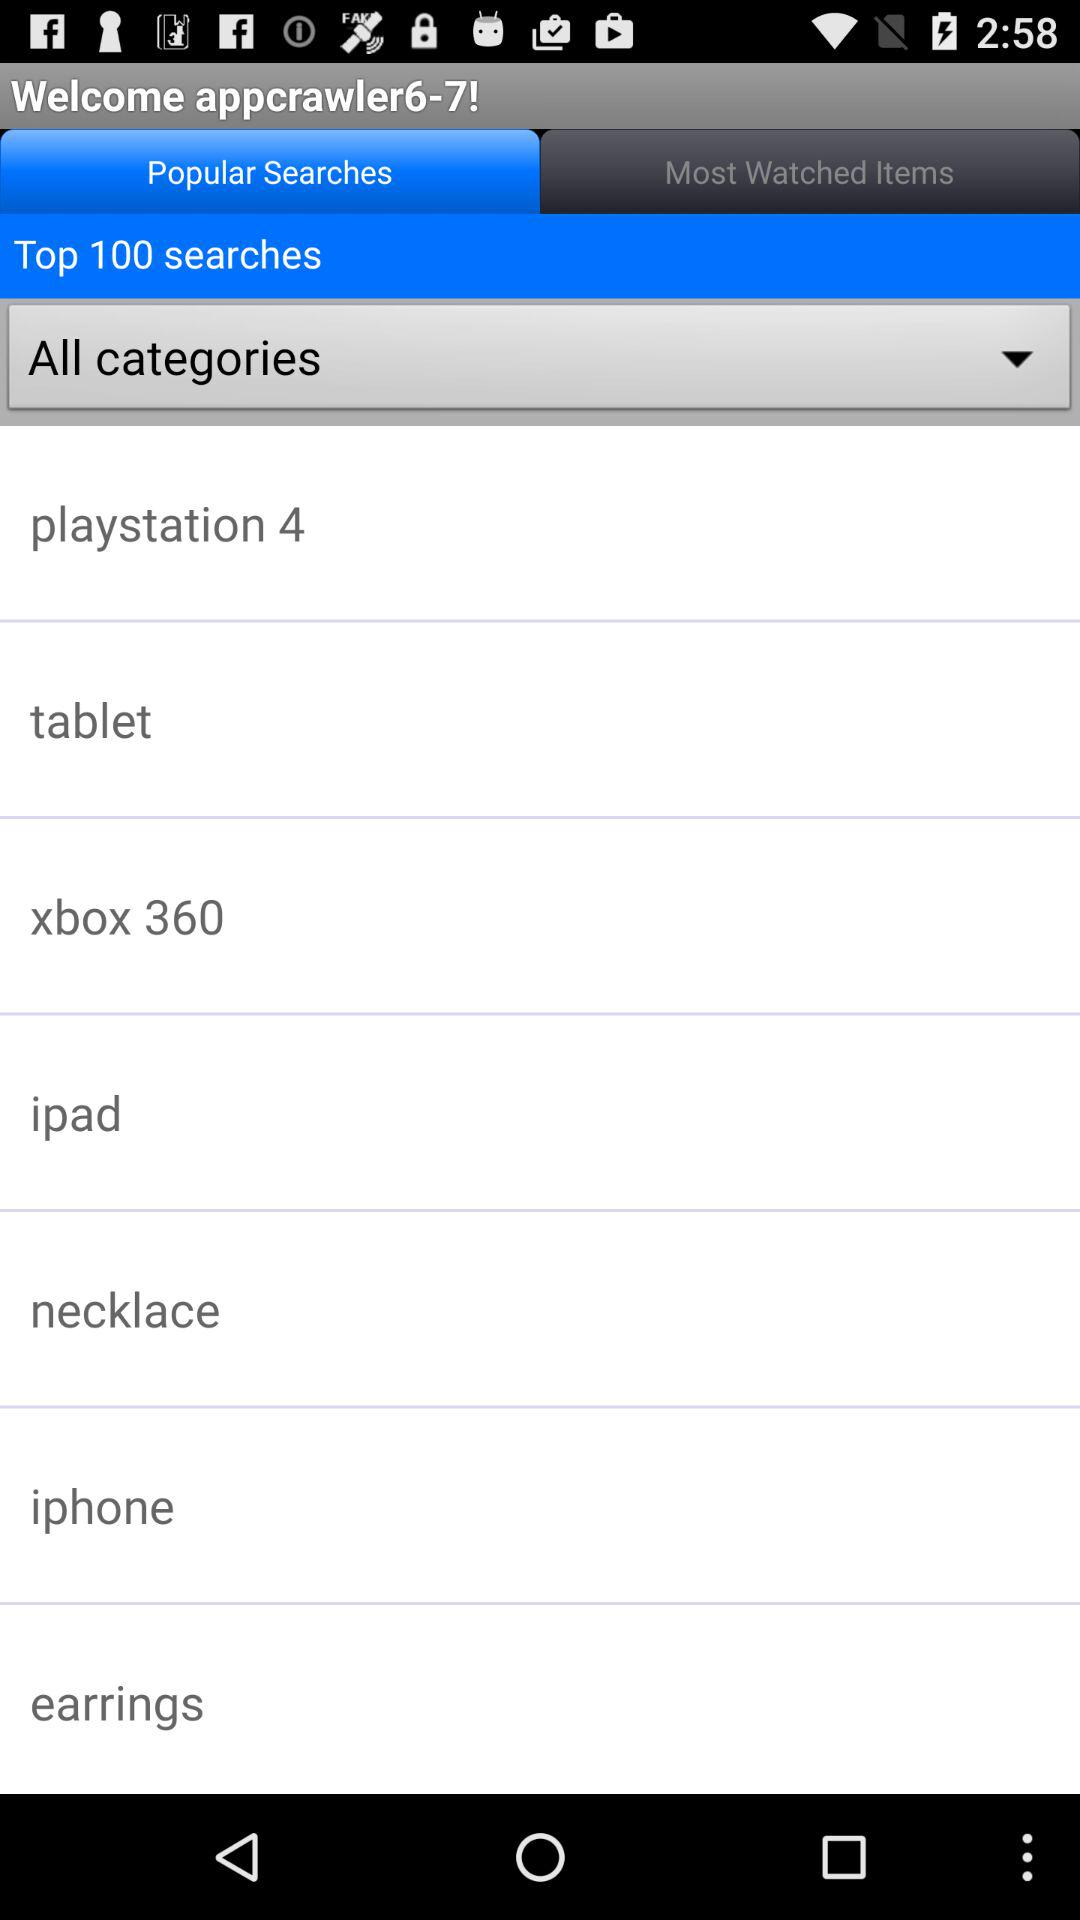What is the user name? The user name is "appcrawler6-7". 